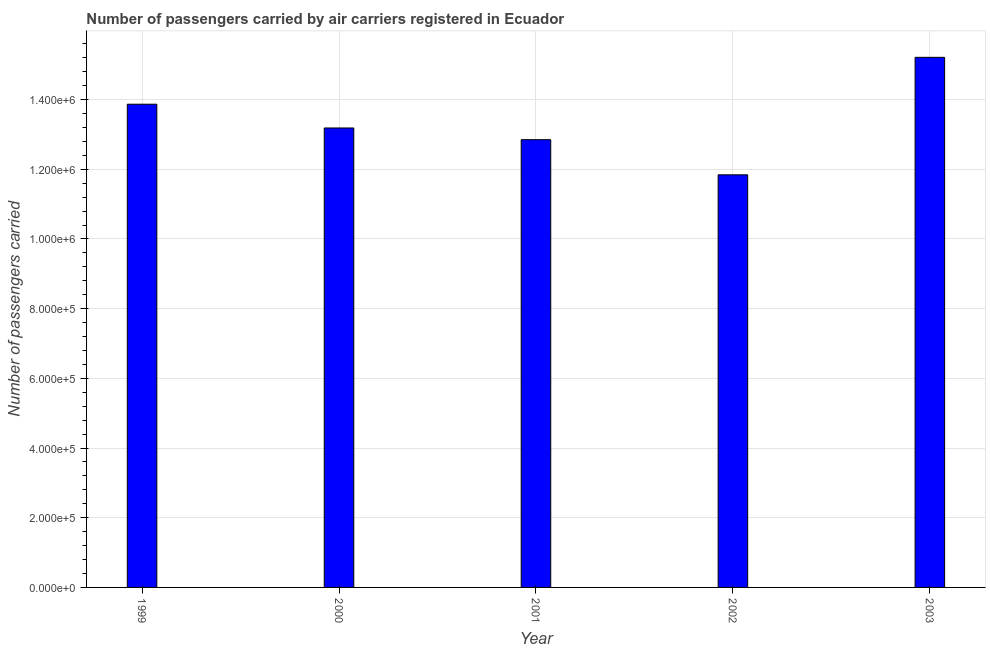Does the graph contain any zero values?
Provide a short and direct response. No. What is the title of the graph?
Offer a very short reply. Number of passengers carried by air carriers registered in Ecuador. What is the label or title of the Y-axis?
Your answer should be compact. Number of passengers carried. What is the number of passengers carried in 2003?
Provide a succinct answer. 1.52e+06. Across all years, what is the maximum number of passengers carried?
Offer a terse response. 1.52e+06. Across all years, what is the minimum number of passengers carried?
Give a very brief answer. 1.18e+06. In which year was the number of passengers carried maximum?
Your response must be concise. 2003. In which year was the number of passengers carried minimum?
Ensure brevity in your answer.  2002. What is the sum of the number of passengers carried?
Your answer should be very brief. 6.70e+06. What is the difference between the number of passengers carried in 2001 and 2002?
Your response must be concise. 1.01e+05. What is the average number of passengers carried per year?
Your answer should be very brief. 1.34e+06. What is the median number of passengers carried?
Your response must be concise. 1.32e+06. In how many years, is the number of passengers carried greater than 440000 ?
Ensure brevity in your answer.  5. What is the ratio of the number of passengers carried in 2002 to that in 2003?
Provide a short and direct response. 0.78. What is the difference between the highest and the second highest number of passengers carried?
Offer a terse response. 1.35e+05. What is the difference between the highest and the lowest number of passengers carried?
Your answer should be compact. 3.37e+05. In how many years, is the number of passengers carried greater than the average number of passengers carried taken over all years?
Provide a short and direct response. 2. How many bars are there?
Your answer should be compact. 5. How many years are there in the graph?
Your answer should be very brief. 5. What is the difference between two consecutive major ticks on the Y-axis?
Make the answer very short. 2.00e+05. Are the values on the major ticks of Y-axis written in scientific E-notation?
Offer a terse response. Yes. What is the Number of passengers carried of 1999?
Make the answer very short. 1.39e+06. What is the Number of passengers carried in 2000?
Make the answer very short. 1.32e+06. What is the Number of passengers carried in 2001?
Give a very brief answer. 1.28e+06. What is the Number of passengers carried in 2002?
Provide a short and direct response. 1.18e+06. What is the Number of passengers carried in 2003?
Your answer should be compact. 1.52e+06. What is the difference between the Number of passengers carried in 1999 and 2000?
Provide a succinct answer. 6.82e+04. What is the difference between the Number of passengers carried in 1999 and 2001?
Make the answer very short. 1.02e+05. What is the difference between the Number of passengers carried in 1999 and 2002?
Your answer should be very brief. 2.03e+05. What is the difference between the Number of passengers carried in 1999 and 2003?
Your answer should be very brief. -1.35e+05. What is the difference between the Number of passengers carried in 2000 and 2001?
Your response must be concise. 3.36e+04. What is the difference between the Number of passengers carried in 2000 and 2002?
Make the answer very short. 1.34e+05. What is the difference between the Number of passengers carried in 2000 and 2003?
Your answer should be compact. -2.03e+05. What is the difference between the Number of passengers carried in 2001 and 2002?
Your answer should be compact. 1.01e+05. What is the difference between the Number of passengers carried in 2001 and 2003?
Your response must be concise. -2.36e+05. What is the difference between the Number of passengers carried in 2002 and 2003?
Your response must be concise. -3.37e+05. What is the ratio of the Number of passengers carried in 1999 to that in 2000?
Keep it short and to the point. 1.05. What is the ratio of the Number of passengers carried in 1999 to that in 2001?
Ensure brevity in your answer.  1.08. What is the ratio of the Number of passengers carried in 1999 to that in 2002?
Provide a succinct answer. 1.17. What is the ratio of the Number of passengers carried in 1999 to that in 2003?
Your answer should be very brief. 0.91. What is the ratio of the Number of passengers carried in 2000 to that in 2002?
Provide a short and direct response. 1.11. What is the ratio of the Number of passengers carried in 2000 to that in 2003?
Your answer should be very brief. 0.87. What is the ratio of the Number of passengers carried in 2001 to that in 2002?
Provide a short and direct response. 1.08. What is the ratio of the Number of passengers carried in 2001 to that in 2003?
Offer a terse response. 0.84. What is the ratio of the Number of passengers carried in 2002 to that in 2003?
Your answer should be very brief. 0.78. 